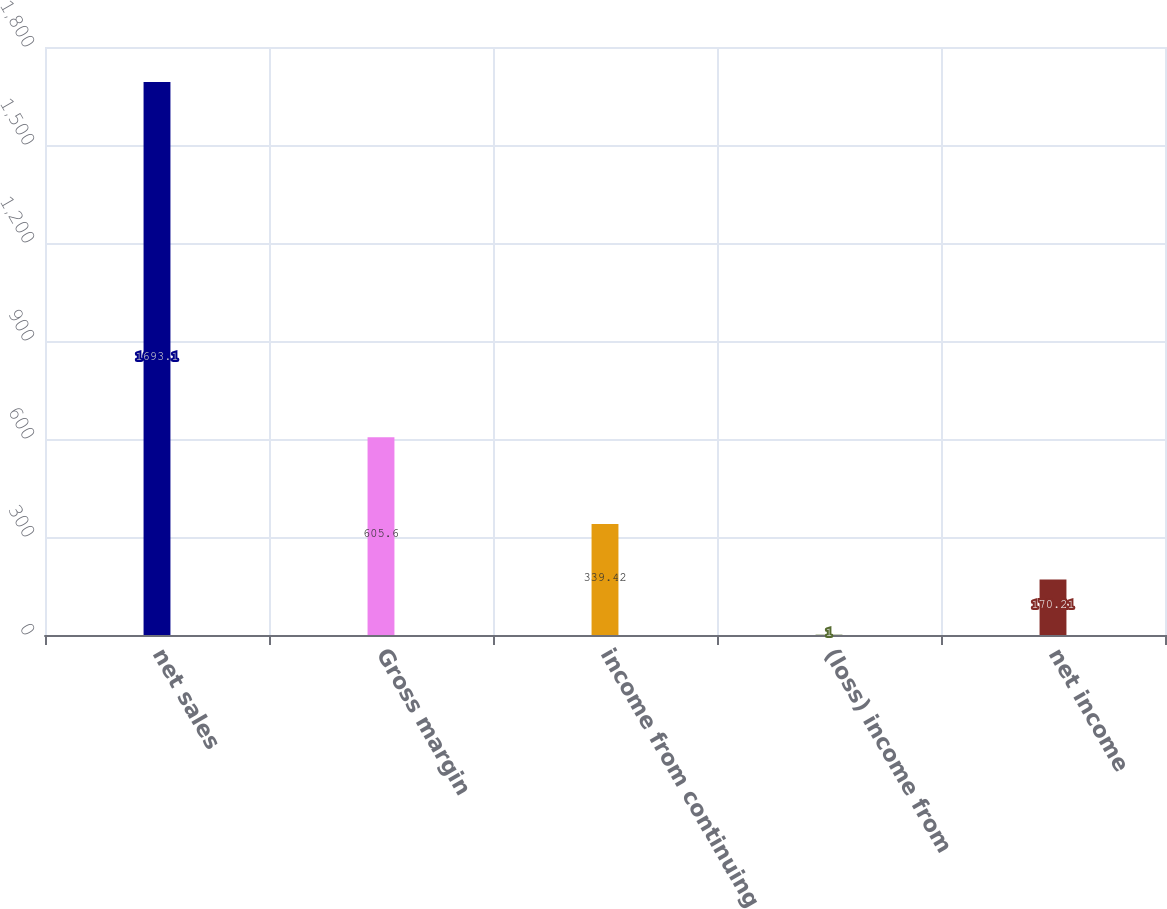Convert chart. <chart><loc_0><loc_0><loc_500><loc_500><bar_chart><fcel>net sales<fcel>Gross margin<fcel>income from continuing<fcel>(loss) income from<fcel>net income<nl><fcel>1693.1<fcel>605.6<fcel>339.42<fcel>1<fcel>170.21<nl></chart> 